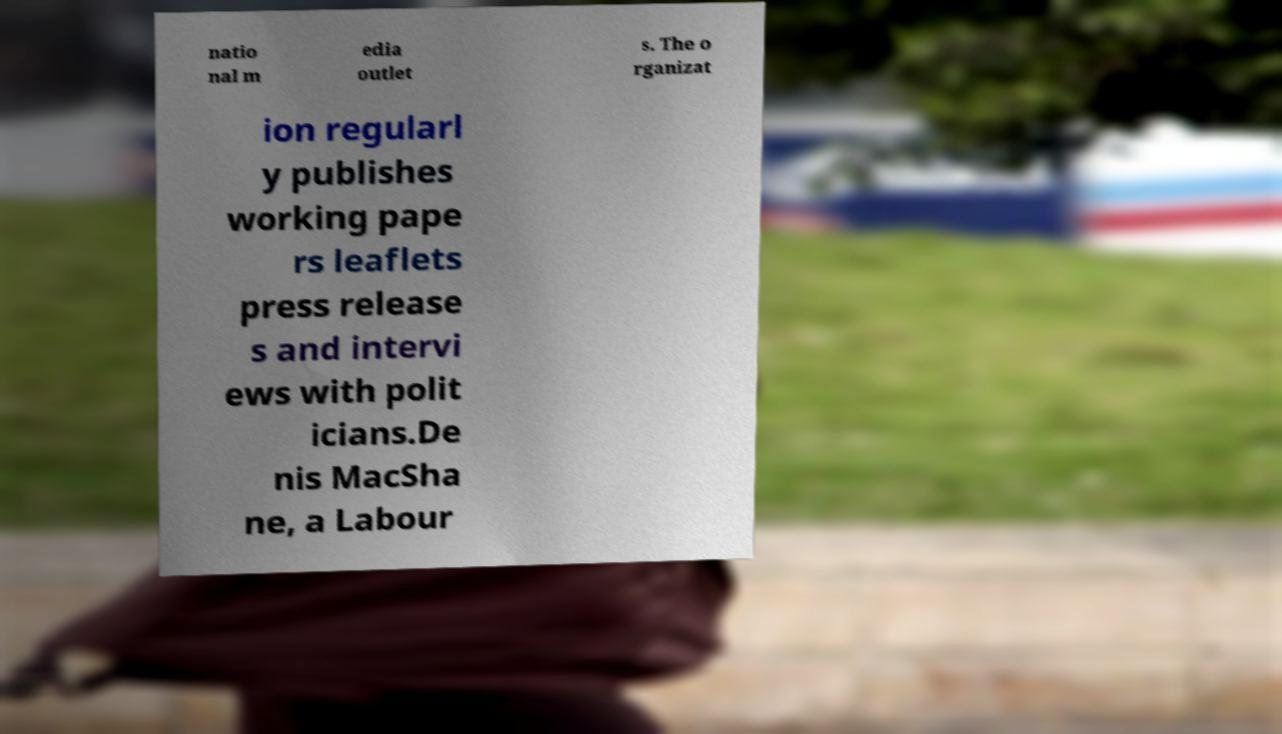I need the written content from this picture converted into text. Can you do that? natio nal m edia outlet s. The o rganizat ion regularl y publishes working pape rs leaflets press release s and intervi ews with polit icians.De nis MacSha ne, a Labour 